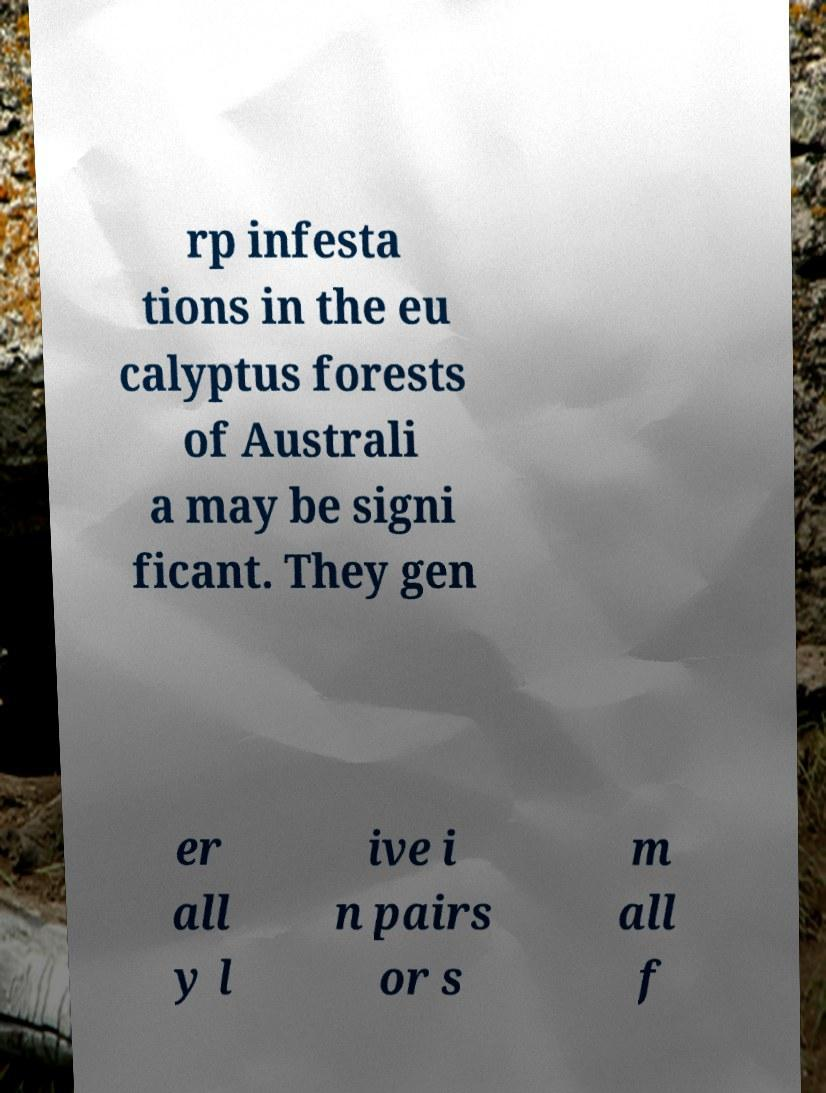For documentation purposes, I need the text within this image transcribed. Could you provide that? rp infesta tions in the eu calyptus forests of Australi a may be signi ficant. They gen er all y l ive i n pairs or s m all f 